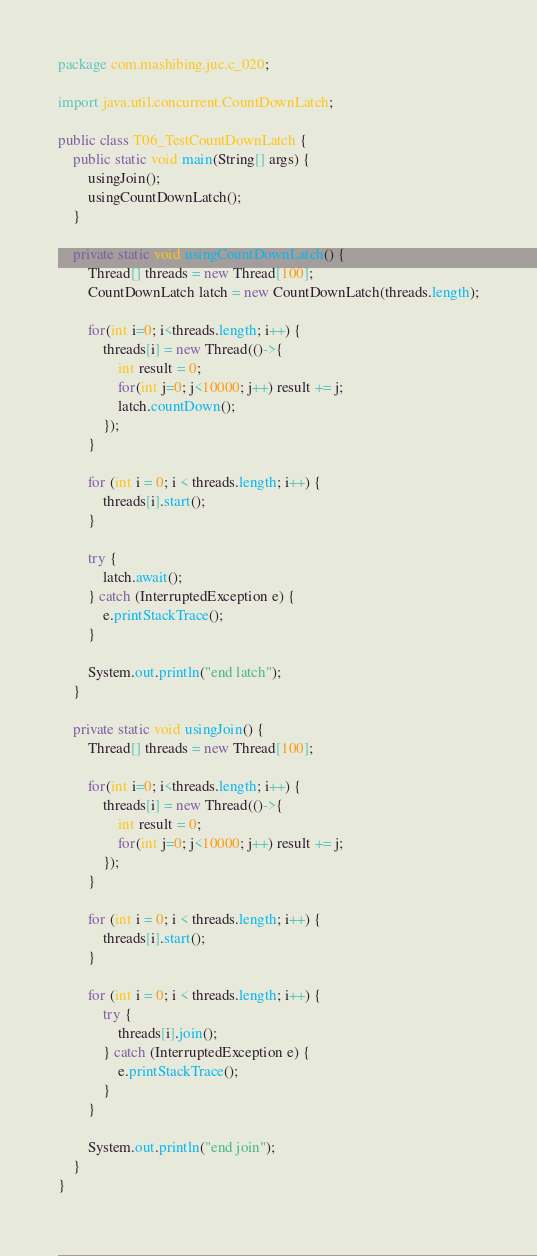Convert code to text. <code><loc_0><loc_0><loc_500><loc_500><_Java_>package com.mashibing.juc.c_020;

import java.util.concurrent.CountDownLatch;

public class T06_TestCountDownLatch {
    public static void main(String[] args) {
        usingJoin();
        usingCountDownLatch();
    }

    private static void usingCountDownLatch() {
        Thread[] threads = new Thread[100];
        CountDownLatch latch = new CountDownLatch(threads.length);

        for(int i=0; i<threads.length; i++) {
            threads[i] = new Thread(()->{
                int result = 0;
                for(int j=0; j<10000; j++) result += j;
                latch.countDown();
            });
        }

        for (int i = 0; i < threads.length; i++) {
            threads[i].start();
        }

        try {
            latch.await();
        } catch (InterruptedException e) {
            e.printStackTrace();
        }

        System.out.println("end latch");
    }

    private static void usingJoin() {
        Thread[] threads = new Thread[100];

        for(int i=0; i<threads.length; i++) {
            threads[i] = new Thread(()->{
                int result = 0;
                for(int j=0; j<10000; j++) result += j;
            });
        }

        for (int i = 0; i < threads.length; i++) {
            threads[i].start();
        }

        for (int i = 0; i < threads.length; i++) {
            try {
                threads[i].join();
            } catch (InterruptedException e) {
                e.printStackTrace();
            }
        }

        System.out.println("end join");
    }
}
</code> 